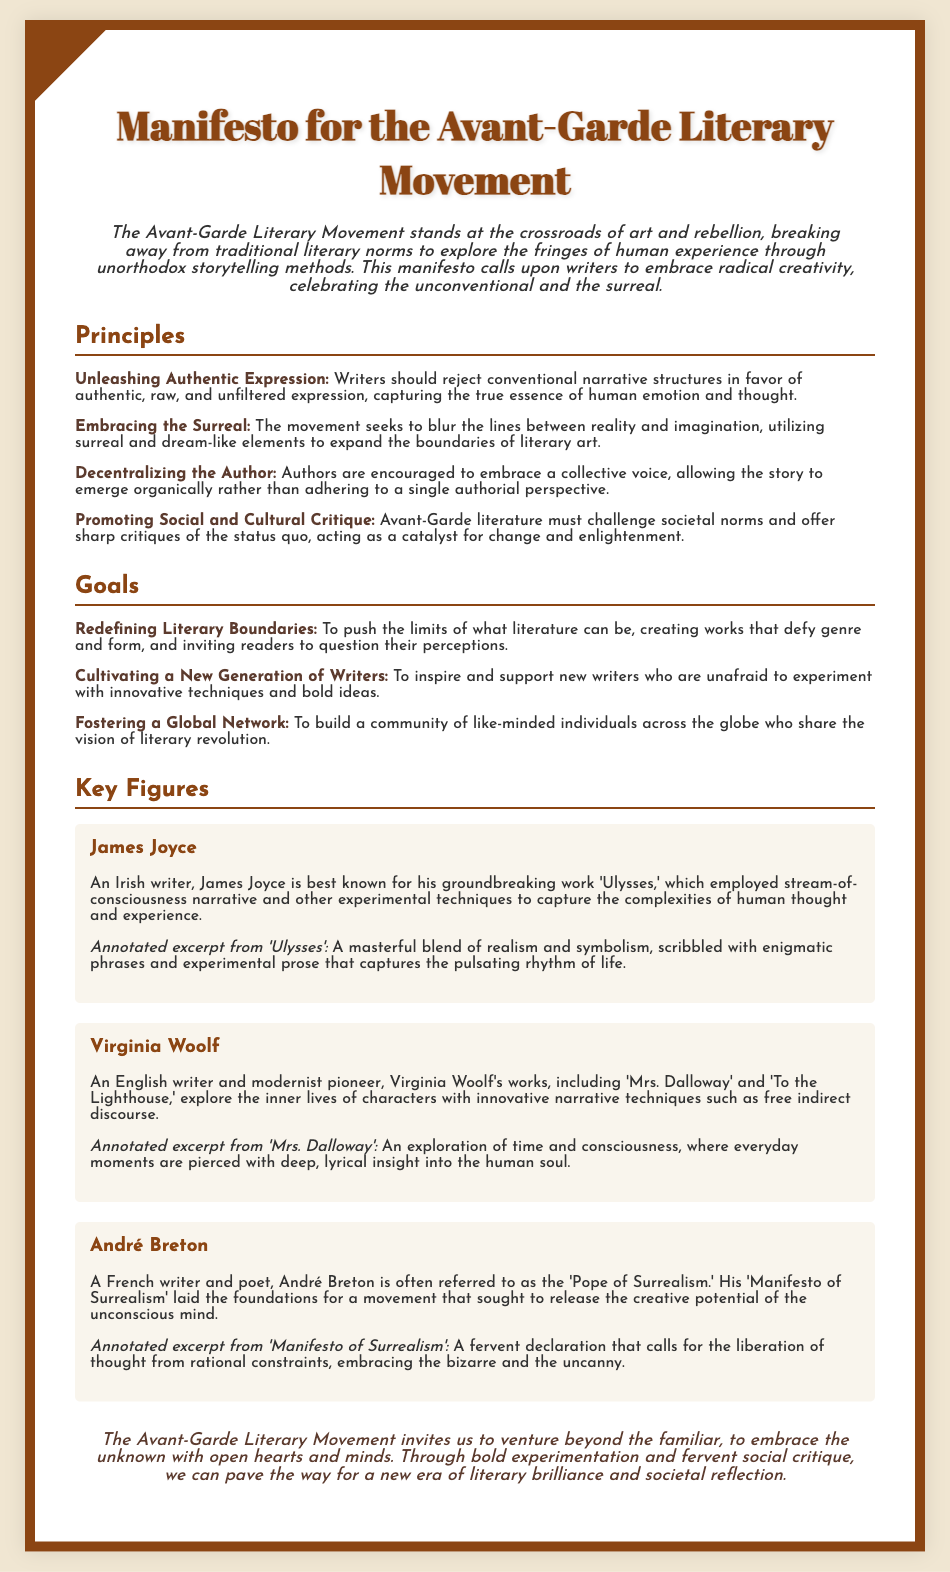What does the manifesto encourage writers to reject? The manifesto encourages writers to reject conventional narrative structures to capture authentic expression.
Answer: Conventional narrative structures Who is referred to as the 'Pope of Surrealism'? André Breton is referred to as the 'Pope of Surrealism' in the document.
Answer: André Breton Name one of the goals of the Avant-Garde Literary Movement. The document lists several goals, one of which is to inspire new writers to experiment.
Answer: Inspiring new writers What key technique is associated with Virginia Woolf's narrative style? The key technique associated with Virginia Woolf's narrative style is free indirect discourse.
Answer: Free indirect discourse How many key figures are mentioned in the document? The document mentions three key figures who contributed to the Avant-Garde Literary Movement.
Answer: Three What is emphasized as a principle regarding the author in the manifesto? The manifesto emphasizes that authors should embrace a collective voice.
Answer: Collective voice Which work by James Joyce is primarily discussed in the document? The document discusses 'Ulysses' as the primary work by James Joyce.
Answer: Ulysses What metaphorical phrase is used to describe the movement's exploration? The document refers to the exploration of the fringes of human experience.
Answer: Fringes of human experience 